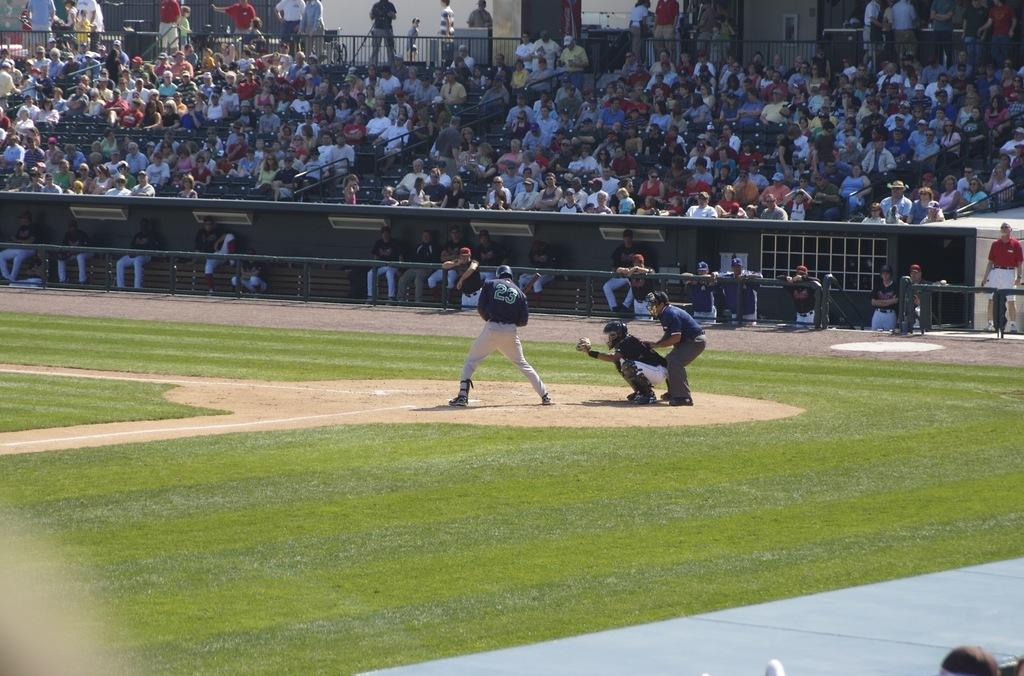What activity are the people in the image engaged in? The people in the image are playing a game. Can you describe the setting of the image? There is a crowd in the background of the image, with some sitting and others standing. What is the purpose of the fence in the image? The fence in the image may serve as a boundary or barrier. What type of surface is visible at the bottom of the image? There is ground visible at the bottom of the image. How many toes can be seen on the people playing the game in the image? There is no specific information about the number of toes visible in the image, as it focuses on the game being played and the surrounding crowd. 